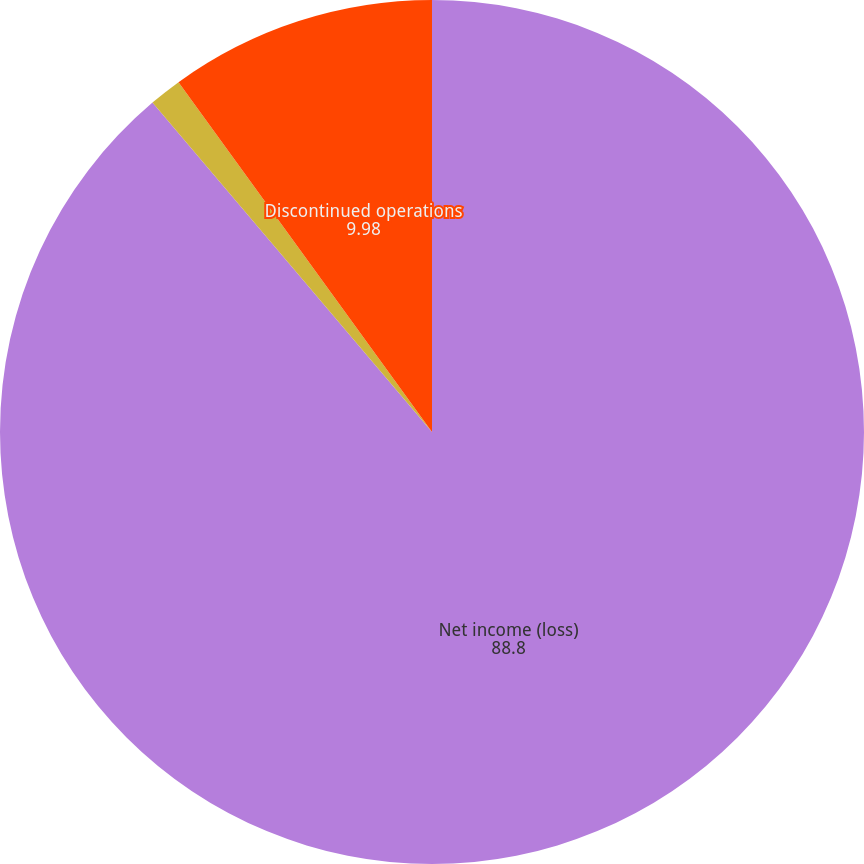Convert chart. <chart><loc_0><loc_0><loc_500><loc_500><pie_chart><fcel>Net income (loss)<fcel>Restructuring and other<fcel>Discontinued operations<nl><fcel>88.8%<fcel>1.22%<fcel>9.98%<nl></chart> 